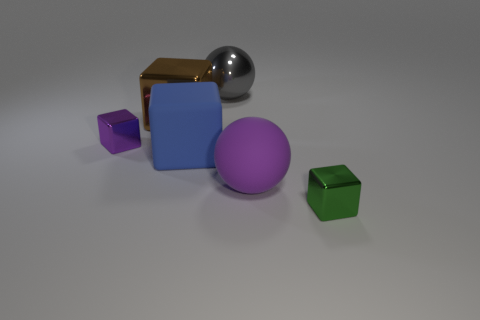Add 3 large blue cubes. How many objects exist? 9 Subtract all shiny cubes. How many cubes are left? 1 Subtract 1 spheres. How many spheres are left? 1 Subtract all purple blocks. How many blocks are left? 3 Subtract all red spheres. How many brown cubes are left? 1 Subtract all blue matte things. Subtract all big purple matte objects. How many objects are left? 4 Add 1 spheres. How many spheres are left? 3 Add 3 gray objects. How many gray objects exist? 4 Subtract 0 brown spheres. How many objects are left? 6 Subtract all balls. How many objects are left? 4 